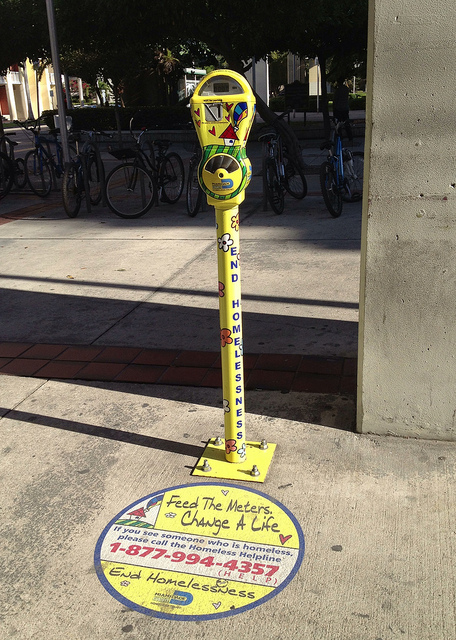Extract all visible text content from this image. END HOMELESSNESS End Homelessness 1-877-994-4357 11 you 500 someone who is homeless Homeless the call please HELP Change A Life Meters The Feed 